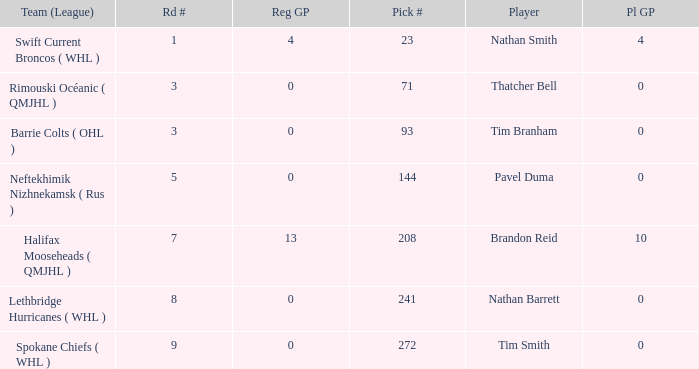How many reg GP for nathan barrett in a round less than 8? 0.0. 